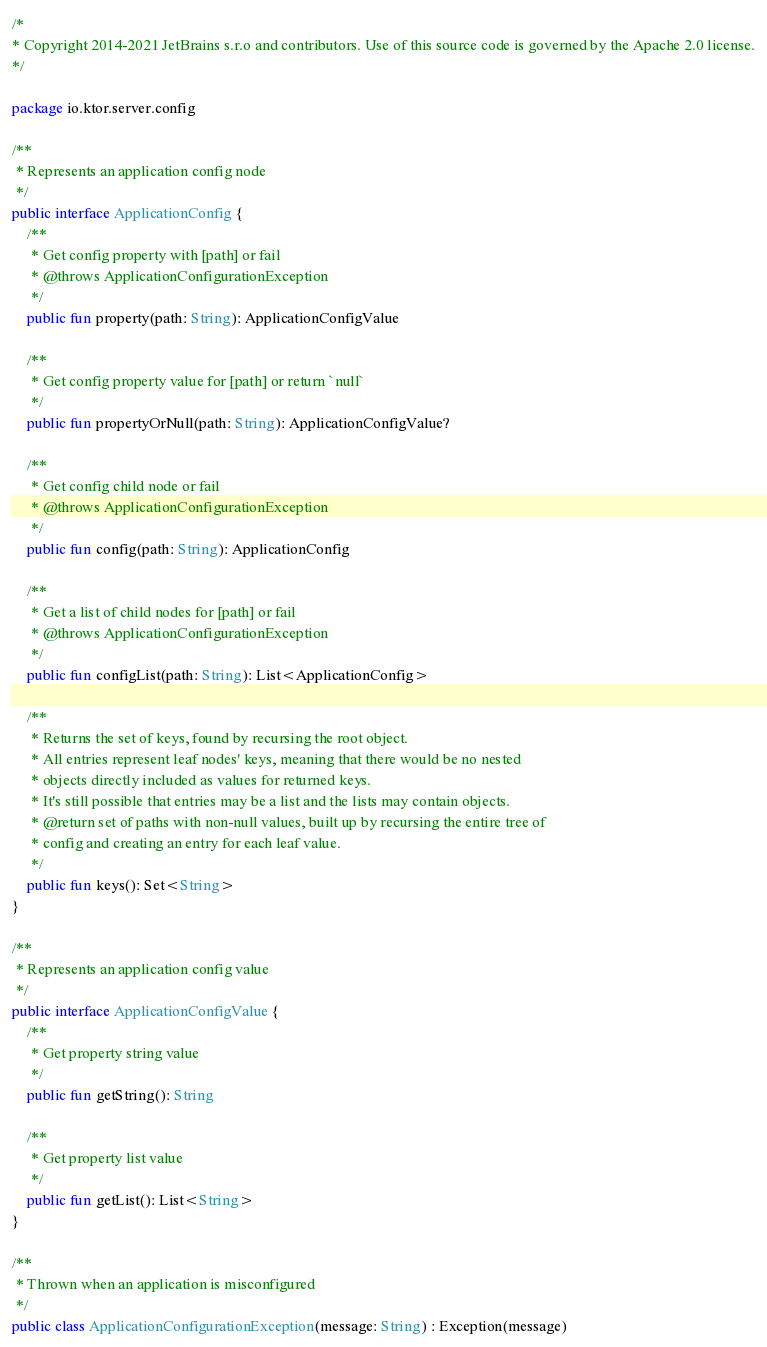<code> <loc_0><loc_0><loc_500><loc_500><_Kotlin_>/*
* Copyright 2014-2021 JetBrains s.r.o and contributors. Use of this source code is governed by the Apache 2.0 license.
*/

package io.ktor.server.config

/**
 * Represents an application config node
 */
public interface ApplicationConfig {
    /**
     * Get config property with [path] or fail
     * @throws ApplicationConfigurationException
     */
    public fun property(path: String): ApplicationConfigValue

    /**
     * Get config property value for [path] or return `null`
     */
    public fun propertyOrNull(path: String): ApplicationConfigValue?

    /**
     * Get config child node or fail
     * @throws ApplicationConfigurationException
     */
    public fun config(path: String): ApplicationConfig

    /**
     * Get a list of child nodes for [path] or fail
     * @throws ApplicationConfigurationException
     */
    public fun configList(path: String): List<ApplicationConfig>

    /**
     * Returns the set of keys, found by recursing the root object.
     * All entries represent leaf nodes' keys, meaning that there would be no nested
     * objects directly included as values for returned keys.
     * It's still possible that entries may be a list and the lists may contain objects.
     * @return set of paths with non-null values, built up by recursing the entire tree of
     * config and creating an entry for each leaf value.
     */
    public fun keys(): Set<String>
}

/**
 * Represents an application config value
 */
public interface ApplicationConfigValue {
    /**
     * Get property string value
     */
    public fun getString(): String

    /**
     * Get property list value
     */
    public fun getList(): List<String>
}

/**
 * Thrown when an application is misconfigured
 */
public class ApplicationConfigurationException(message: String) : Exception(message)
</code> 